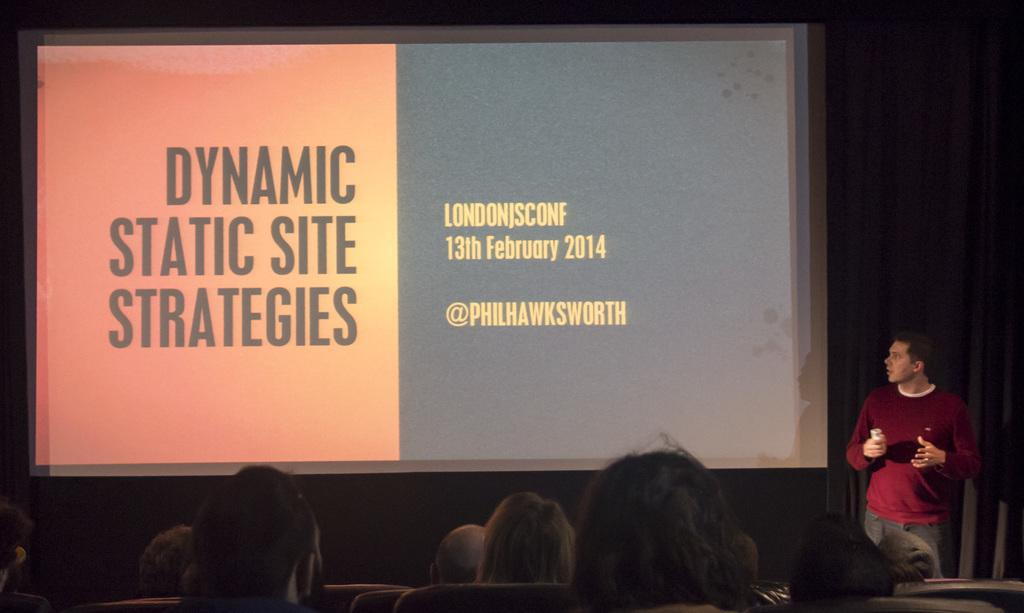What are the people in the image doing? There are people sitting at the bottom of the image. Is there anyone standing among the sitting people? Yes, a person is standing in front of the sitting people. What is the standing person holding in his hand? The standing person is holding something in his hand. What can be seen on the wall in the image? There is a wall in the image with a screen on it. What type of curtain is hanging in front of the screen in the image? There is no curtain present in the image; only a wall with a screen on it is visible. 